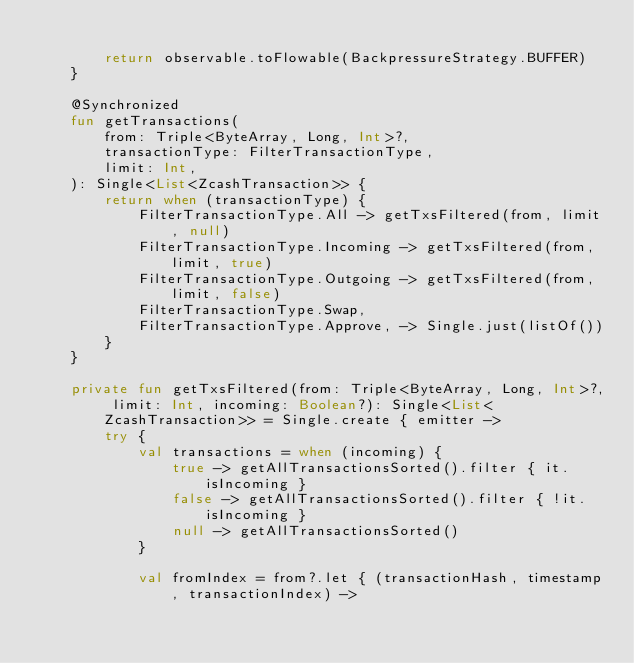<code> <loc_0><loc_0><loc_500><loc_500><_Kotlin_>
        return observable.toFlowable(BackpressureStrategy.BUFFER)
    }

    @Synchronized
    fun getTransactions(
        from: Triple<ByteArray, Long, Int>?,
        transactionType: FilterTransactionType,
        limit: Int,
    ): Single<List<ZcashTransaction>> {
        return when (transactionType) {
            FilterTransactionType.All -> getTxsFiltered(from, limit, null)
            FilterTransactionType.Incoming -> getTxsFiltered(from, limit, true)
            FilterTransactionType.Outgoing -> getTxsFiltered(from, limit, false)
            FilterTransactionType.Swap,
            FilterTransactionType.Approve, -> Single.just(listOf())
        }
    }

    private fun getTxsFiltered(from: Triple<ByteArray, Long, Int>?, limit: Int, incoming: Boolean?): Single<List<ZcashTransaction>> = Single.create { emitter ->
        try {
            val transactions = when (incoming) {
                true -> getAllTransactionsSorted().filter { it.isIncoming }
                false -> getAllTransactionsSorted().filter { !it.isIncoming }
                null -> getAllTransactionsSorted()
            }

            val fromIndex = from?.let { (transactionHash, timestamp, transactionIndex) -></code> 